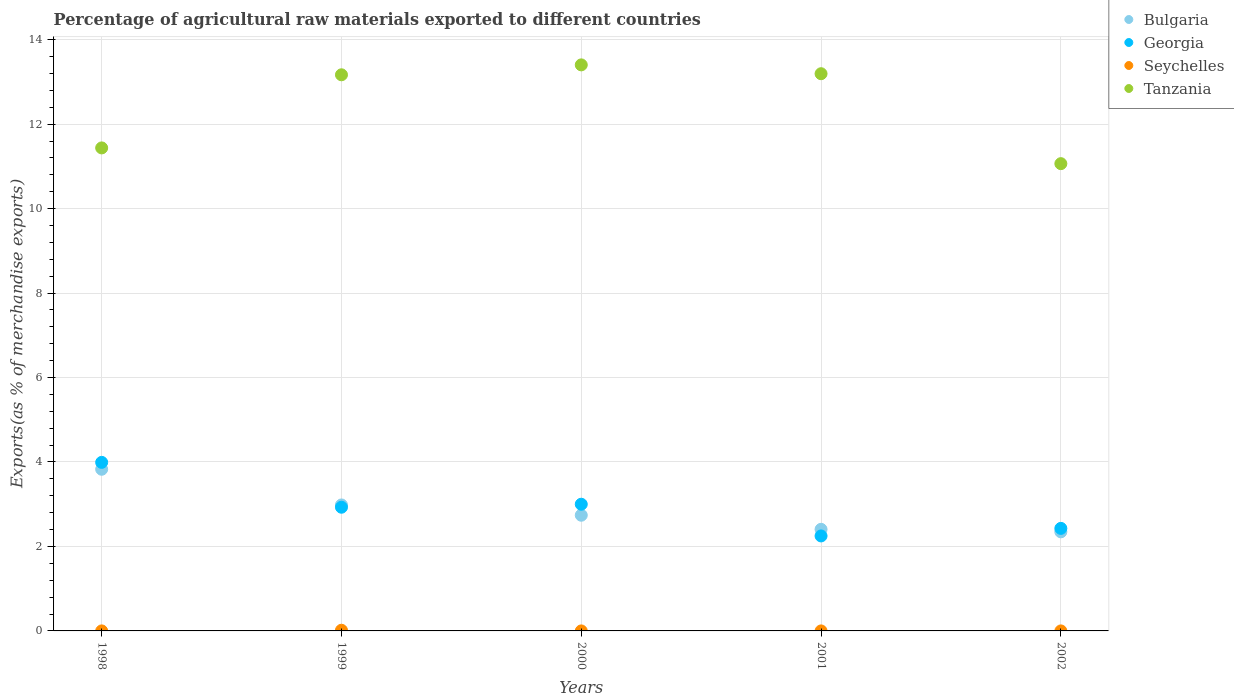How many different coloured dotlines are there?
Offer a terse response. 4. What is the percentage of exports to different countries in Bulgaria in 2000?
Provide a succinct answer. 2.74. Across all years, what is the maximum percentage of exports to different countries in Seychelles?
Your response must be concise. 0.02. Across all years, what is the minimum percentage of exports to different countries in Georgia?
Provide a succinct answer. 2.25. In which year was the percentage of exports to different countries in Georgia maximum?
Make the answer very short. 1998. What is the total percentage of exports to different countries in Seychelles in the graph?
Give a very brief answer. 0.02. What is the difference between the percentage of exports to different countries in Tanzania in 1999 and that in 2002?
Your answer should be very brief. 2.1. What is the difference between the percentage of exports to different countries in Georgia in 2002 and the percentage of exports to different countries in Bulgaria in 1999?
Your answer should be very brief. -0.55. What is the average percentage of exports to different countries in Bulgaria per year?
Your answer should be very brief. 2.86. In the year 1999, what is the difference between the percentage of exports to different countries in Seychelles and percentage of exports to different countries in Bulgaria?
Your response must be concise. -2.97. In how many years, is the percentage of exports to different countries in Tanzania greater than 12.8 %?
Ensure brevity in your answer.  3. What is the ratio of the percentage of exports to different countries in Georgia in 1999 to that in 2002?
Provide a succinct answer. 1.21. Is the percentage of exports to different countries in Tanzania in 1998 less than that in 2001?
Make the answer very short. Yes. What is the difference between the highest and the second highest percentage of exports to different countries in Bulgaria?
Give a very brief answer. 0.85. What is the difference between the highest and the lowest percentage of exports to different countries in Georgia?
Offer a very short reply. 1.74. In how many years, is the percentage of exports to different countries in Seychelles greater than the average percentage of exports to different countries in Seychelles taken over all years?
Your answer should be compact. 1. Is it the case that in every year, the sum of the percentage of exports to different countries in Georgia and percentage of exports to different countries in Tanzania  is greater than the sum of percentage of exports to different countries in Seychelles and percentage of exports to different countries in Bulgaria?
Your answer should be compact. Yes. How many dotlines are there?
Provide a succinct answer. 4. What is the difference between two consecutive major ticks on the Y-axis?
Offer a terse response. 2. How are the legend labels stacked?
Your response must be concise. Vertical. What is the title of the graph?
Offer a very short reply. Percentage of agricultural raw materials exported to different countries. What is the label or title of the X-axis?
Offer a terse response. Years. What is the label or title of the Y-axis?
Offer a very short reply. Exports(as % of merchandise exports). What is the Exports(as % of merchandise exports) of Bulgaria in 1998?
Provide a succinct answer. 3.83. What is the Exports(as % of merchandise exports) in Georgia in 1998?
Provide a short and direct response. 3.99. What is the Exports(as % of merchandise exports) of Seychelles in 1998?
Keep it short and to the point. 0. What is the Exports(as % of merchandise exports) in Tanzania in 1998?
Keep it short and to the point. 11.44. What is the Exports(as % of merchandise exports) of Bulgaria in 1999?
Make the answer very short. 2.98. What is the Exports(as % of merchandise exports) in Georgia in 1999?
Your answer should be compact. 2.93. What is the Exports(as % of merchandise exports) of Seychelles in 1999?
Keep it short and to the point. 0.02. What is the Exports(as % of merchandise exports) of Tanzania in 1999?
Offer a terse response. 13.17. What is the Exports(as % of merchandise exports) of Bulgaria in 2000?
Provide a succinct answer. 2.74. What is the Exports(as % of merchandise exports) of Georgia in 2000?
Keep it short and to the point. 3. What is the Exports(as % of merchandise exports) in Seychelles in 2000?
Ensure brevity in your answer.  0. What is the Exports(as % of merchandise exports) of Tanzania in 2000?
Offer a very short reply. 13.4. What is the Exports(as % of merchandise exports) of Bulgaria in 2001?
Your response must be concise. 2.41. What is the Exports(as % of merchandise exports) of Georgia in 2001?
Keep it short and to the point. 2.25. What is the Exports(as % of merchandise exports) of Seychelles in 2001?
Your answer should be compact. 0. What is the Exports(as % of merchandise exports) of Tanzania in 2001?
Ensure brevity in your answer.  13.19. What is the Exports(as % of merchandise exports) of Bulgaria in 2002?
Keep it short and to the point. 2.35. What is the Exports(as % of merchandise exports) in Georgia in 2002?
Offer a terse response. 2.43. What is the Exports(as % of merchandise exports) in Seychelles in 2002?
Offer a very short reply. 0. What is the Exports(as % of merchandise exports) in Tanzania in 2002?
Make the answer very short. 11.06. Across all years, what is the maximum Exports(as % of merchandise exports) in Bulgaria?
Offer a very short reply. 3.83. Across all years, what is the maximum Exports(as % of merchandise exports) of Georgia?
Give a very brief answer. 3.99. Across all years, what is the maximum Exports(as % of merchandise exports) of Seychelles?
Ensure brevity in your answer.  0.02. Across all years, what is the maximum Exports(as % of merchandise exports) of Tanzania?
Offer a very short reply. 13.4. Across all years, what is the minimum Exports(as % of merchandise exports) of Bulgaria?
Ensure brevity in your answer.  2.35. Across all years, what is the minimum Exports(as % of merchandise exports) in Georgia?
Provide a succinct answer. 2.25. Across all years, what is the minimum Exports(as % of merchandise exports) in Seychelles?
Ensure brevity in your answer.  0. Across all years, what is the minimum Exports(as % of merchandise exports) in Tanzania?
Your answer should be compact. 11.06. What is the total Exports(as % of merchandise exports) in Bulgaria in the graph?
Ensure brevity in your answer.  14.3. What is the total Exports(as % of merchandise exports) in Georgia in the graph?
Provide a succinct answer. 14.6. What is the total Exports(as % of merchandise exports) of Seychelles in the graph?
Your answer should be compact. 0.02. What is the total Exports(as % of merchandise exports) in Tanzania in the graph?
Provide a short and direct response. 62.27. What is the difference between the Exports(as % of merchandise exports) in Bulgaria in 1998 and that in 1999?
Your response must be concise. 0.85. What is the difference between the Exports(as % of merchandise exports) in Georgia in 1998 and that in 1999?
Give a very brief answer. 1.06. What is the difference between the Exports(as % of merchandise exports) in Seychelles in 1998 and that in 1999?
Ensure brevity in your answer.  -0.02. What is the difference between the Exports(as % of merchandise exports) in Tanzania in 1998 and that in 1999?
Give a very brief answer. -1.73. What is the difference between the Exports(as % of merchandise exports) in Bulgaria in 1998 and that in 2000?
Your answer should be compact. 1.09. What is the difference between the Exports(as % of merchandise exports) in Georgia in 1998 and that in 2000?
Offer a terse response. 0.99. What is the difference between the Exports(as % of merchandise exports) in Tanzania in 1998 and that in 2000?
Your answer should be compact. -1.97. What is the difference between the Exports(as % of merchandise exports) in Bulgaria in 1998 and that in 2001?
Keep it short and to the point. 1.42. What is the difference between the Exports(as % of merchandise exports) of Georgia in 1998 and that in 2001?
Offer a very short reply. 1.74. What is the difference between the Exports(as % of merchandise exports) in Tanzania in 1998 and that in 2001?
Make the answer very short. -1.76. What is the difference between the Exports(as % of merchandise exports) of Bulgaria in 1998 and that in 2002?
Your answer should be very brief. 1.48. What is the difference between the Exports(as % of merchandise exports) in Georgia in 1998 and that in 2002?
Offer a terse response. 1.56. What is the difference between the Exports(as % of merchandise exports) of Seychelles in 1998 and that in 2002?
Ensure brevity in your answer.  0. What is the difference between the Exports(as % of merchandise exports) in Tanzania in 1998 and that in 2002?
Your answer should be compact. 0.37. What is the difference between the Exports(as % of merchandise exports) in Bulgaria in 1999 and that in 2000?
Give a very brief answer. 0.24. What is the difference between the Exports(as % of merchandise exports) in Georgia in 1999 and that in 2000?
Your answer should be very brief. -0.07. What is the difference between the Exports(as % of merchandise exports) of Seychelles in 1999 and that in 2000?
Offer a very short reply. 0.02. What is the difference between the Exports(as % of merchandise exports) in Tanzania in 1999 and that in 2000?
Keep it short and to the point. -0.23. What is the difference between the Exports(as % of merchandise exports) of Bulgaria in 1999 and that in 2001?
Provide a succinct answer. 0.58. What is the difference between the Exports(as % of merchandise exports) in Georgia in 1999 and that in 2001?
Keep it short and to the point. 0.68. What is the difference between the Exports(as % of merchandise exports) in Seychelles in 1999 and that in 2001?
Ensure brevity in your answer.  0.02. What is the difference between the Exports(as % of merchandise exports) of Tanzania in 1999 and that in 2001?
Offer a terse response. -0.03. What is the difference between the Exports(as % of merchandise exports) in Bulgaria in 1999 and that in 2002?
Provide a short and direct response. 0.64. What is the difference between the Exports(as % of merchandise exports) in Georgia in 1999 and that in 2002?
Your answer should be very brief. 0.5. What is the difference between the Exports(as % of merchandise exports) of Seychelles in 1999 and that in 2002?
Keep it short and to the point. 0.02. What is the difference between the Exports(as % of merchandise exports) of Tanzania in 1999 and that in 2002?
Your answer should be compact. 2.1. What is the difference between the Exports(as % of merchandise exports) of Bulgaria in 2000 and that in 2001?
Provide a short and direct response. 0.33. What is the difference between the Exports(as % of merchandise exports) of Georgia in 2000 and that in 2001?
Your response must be concise. 0.75. What is the difference between the Exports(as % of merchandise exports) of Seychelles in 2000 and that in 2001?
Offer a terse response. -0. What is the difference between the Exports(as % of merchandise exports) in Tanzania in 2000 and that in 2001?
Give a very brief answer. 0.21. What is the difference between the Exports(as % of merchandise exports) in Bulgaria in 2000 and that in 2002?
Your answer should be compact. 0.39. What is the difference between the Exports(as % of merchandise exports) in Georgia in 2000 and that in 2002?
Offer a very short reply. 0.57. What is the difference between the Exports(as % of merchandise exports) of Seychelles in 2000 and that in 2002?
Give a very brief answer. -0. What is the difference between the Exports(as % of merchandise exports) in Tanzania in 2000 and that in 2002?
Make the answer very short. 2.34. What is the difference between the Exports(as % of merchandise exports) of Bulgaria in 2001 and that in 2002?
Provide a succinct answer. 0.06. What is the difference between the Exports(as % of merchandise exports) in Georgia in 2001 and that in 2002?
Your answer should be very brief. -0.18. What is the difference between the Exports(as % of merchandise exports) of Seychelles in 2001 and that in 2002?
Offer a terse response. 0. What is the difference between the Exports(as % of merchandise exports) in Tanzania in 2001 and that in 2002?
Your answer should be compact. 2.13. What is the difference between the Exports(as % of merchandise exports) in Bulgaria in 1998 and the Exports(as % of merchandise exports) in Georgia in 1999?
Keep it short and to the point. 0.9. What is the difference between the Exports(as % of merchandise exports) in Bulgaria in 1998 and the Exports(as % of merchandise exports) in Seychelles in 1999?
Offer a very short reply. 3.81. What is the difference between the Exports(as % of merchandise exports) of Bulgaria in 1998 and the Exports(as % of merchandise exports) of Tanzania in 1999?
Provide a succinct answer. -9.34. What is the difference between the Exports(as % of merchandise exports) in Georgia in 1998 and the Exports(as % of merchandise exports) in Seychelles in 1999?
Ensure brevity in your answer.  3.97. What is the difference between the Exports(as % of merchandise exports) in Georgia in 1998 and the Exports(as % of merchandise exports) in Tanzania in 1999?
Your answer should be compact. -9.18. What is the difference between the Exports(as % of merchandise exports) of Seychelles in 1998 and the Exports(as % of merchandise exports) of Tanzania in 1999?
Offer a very short reply. -13.17. What is the difference between the Exports(as % of merchandise exports) in Bulgaria in 1998 and the Exports(as % of merchandise exports) in Georgia in 2000?
Provide a short and direct response. 0.83. What is the difference between the Exports(as % of merchandise exports) of Bulgaria in 1998 and the Exports(as % of merchandise exports) of Seychelles in 2000?
Provide a succinct answer. 3.83. What is the difference between the Exports(as % of merchandise exports) of Bulgaria in 1998 and the Exports(as % of merchandise exports) of Tanzania in 2000?
Ensure brevity in your answer.  -9.58. What is the difference between the Exports(as % of merchandise exports) of Georgia in 1998 and the Exports(as % of merchandise exports) of Seychelles in 2000?
Your response must be concise. 3.99. What is the difference between the Exports(as % of merchandise exports) of Georgia in 1998 and the Exports(as % of merchandise exports) of Tanzania in 2000?
Offer a very short reply. -9.41. What is the difference between the Exports(as % of merchandise exports) of Seychelles in 1998 and the Exports(as % of merchandise exports) of Tanzania in 2000?
Provide a short and direct response. -13.4. What is the difference between the Exports(as % of merchandise exports) of Bulgaria in 1998 and the Exports(as % of merchandise exports) of Georgia in 2001?
Offer a very short reply. 1.58. What is the difference between the Exports(as % of merchandise exports) in Bulgaria in 1998 and the Exports(as % of merchandise exports) in Seychelles in 2001?
Offer a terse response. 3.83. What is the difference between the Exports(as % of merchandise exports) in Bulgaria in 1998 and the Exports(as % of merchandise exports) in Tanzania in 2001?
Your answer should be very brief. -9.37. What is the difference between the Exports(as % of merchandise exports) in Georgia in 1998 and the Exports(as % of merchandise exports) in Seychelles in 2001?
Your answer should be compact. 3.99. What is the difference between the Exports(as % of merchandise exports) of Georgia in 1998 and the Exports(as % of merchandise exports) of Tanzania in 2001?
Offer a terse response. -9.2. What is the difference between the Exports(as % of merchandise exports) of Seychelles in 1998 and the Exports(as % of merchandise exports) of Tanzania in 2001?
Your response must be concise. -13.19. What is the difference between the Exports(as % of merchandise exports) of Bulgaria in 1998 and the Exports(as % of merchandise exports) of Georgia in 2002?
Offer a terse response. 1.4. What is the difference between the Exports(as % of merchandise exports) in Bulgaria in 1998 and the Exports(as % of merchandise exports) in Seychelles in 2002?
Keep it short and to the point. 3.83. What is the difference between the Exports(as % of merchandise exports) in Bulgaria in 1998 and the Exports(as % of merchandise exports) in Tanzania in 2002?
Give a very brief answer. -7.24. What is the difference between the Exports(as % of merchandise exports) of Georgia in 1998 and the Exports(as % of merchandise exports) of Seychelles in 2002?
Give a very brief answer. 3.99. What is the difference between the Exports(as % of merchandise exports) of Georgia in 1998 and the Exports(as % of merchandise exports) of Tanzania in 2002?
Provide a short and direct response. -7.07. What is the difference between the Exports(as % of merchandise exports) of Seychelles in 1998 and the Exports(as % of merchandise exports) of Tanzania in 2002?
Give a very brief answer. -11.06. What is the difference between the Exports(as % of merchandise exports) in Bulgaria in 1999 and the Exports(as % of merchandise exports) in Georgia in 2000?
Make the answer very short. -0.02. What is the difference between the Exports(as % of merchandise exports) of Bulgaria in 1999 and the Exports(as % of merchandise exports) of Seychelles in 2000?
Your response must be concise. 2.98. What is the difference between the Exports(as % of merchandise exports) in Bulgaria in 1999 and the Exports(as % of merchandise exports) in Tanzania in 2000?
Your response must be concise. -10.42. What is the difference between the Exports(as % of merchandise exports) in Georgia in 1999 and the Exports(as % of merchandise exports) in Seychelles in 2000?
Ensure brevity in your answer.  2.93. What is the difference between the Exports(as % of merchandise exports) in Georgia in 1999 and the Exports(as % of merchandise exports) in Tanzania in 2000?
Offer a very short reply. -10.47. What is the difference between the Exports(as % of merchandise exports) in Seychelles in 1999 and the Exports(as % of merchandise exports) in Tanzania in 2000?
Make the answer very short. -13.39. What is the difference between the Exports(as % of merchandise exports) of Bulgaria in 1999 and the Exports(as % of merchandise exports) of Georgia in 2001?
Provide a short and direct response. 0.73. What is the difference between the Exports(as % of merchandise exports) in Bulgaria in 1999 and the Exports(as % of merchandise exports) in Seychelles in 2001?
Your answer should be compact. 2.98. What is the difference between the Exports(as % of merchandise exports) in Bulgaria in 1999 and the Exports(as % of merchandise exports) in Tanzania in 2001?
Make the answer very short. -10.21. What is the difference between the Exports(as % of merchandise exports) in Georgia in 1999 and the Exports(as % of merchandise exports) in Seychelles in 2001?
Provide a short and direct response. 2.93. What is the difference between the Exports(as % of merchandise exports) of Georgia in 1999 and the Exports(as % of merchandise exports) of Tanzania in 2001?
Keep it short and to the point. -10.26. What is the difference between the Exports(as % of merchandise exports) of Seychelles in 1999 and the Exports(as % of merchandise exports) of Tanzania in 2001?
Provide a short and direct response. -13.18. What is the difference between the Exports(as % of merchandise exports) of Bulgaria in 1999 and the Exports(as % of merchandise exports) of Georgia in 2002?
Offer a very short reply. 0.55. What is the difference between the Exports(as % of merchandise exports) in Bulgaria in 1999 and the Exports(as % of merchandise exports) in Seychelles in 2002?
Ensure brevity in your answer.  2.98. What is the difference between the Exports(as % of merchandise exports) of Bulgaria in 1999 and the Exports(as % of merchandise exports) of Tanzania in 2002?
Offer a terse response. -8.08. What is the difference between the Exports(as % of merchandise exports) of Georgia in 1999 and the Exports(as % of merchandise exports) of Seychelles in 2002?
Give a very brief answer. 2.93. What is the difference between the Exports(as % of merchandise exports) in Georgia in 1999 and the Exports(as % of merchandise exports) in Tanzania in 2002?
Your answer should be compact. -8.14. What is the difference between the Exports(as % of merchandise exports) of Seychelles in 1999 and the Exports(as % of merchandise exports) of Tanzania in 2002?
Your answer should be compact. -11.05. What is the difference between the Exports(as % of merchandise exports) of Bulgaria in 2000 and the Exports(as % of merchandise exports) of Georgia in 2001?
Offer a very short reply. 0.49. What is the difference between the Exports(as % of merchandise exports) of Bulgaria in 2000 and the Exports(as % of merchandise exports) of Seychelles in 2001?
Give a very brief answer. 2.74. What is the difference between the Exports(as % of merchandise exports) of Bulgaria in 2000 and the Exports(as % of merchandise exports) of Tanzania in 2001?
Offer a terse response. -10.45. What is the difference between the Exports(as % of merchandise exports) in Georgia in 2000 and the Exports(as % of merchandise exports) in Seychelles in 2001?
Ensure brevity in your answer.  3. What is the difference between the Exports(as % of merchandise exports) of Georgia in 2000 and the Exports(as % of merchandise exports) of Tanzania in 2001?
Your response must be concise. -10.19. What is the difference between the Exports(as % of merchandise exports) in Seychelles in 2000 and the Exports(as % of merchandise exports) in Tanzania in 2001?
Offer a terse response. -13.19. What is the difference between the Exports(as % of merchandise exports) of Bulgaria in 2000 and the Exports(as % of merchandise exports) of Georgia in 2002?
Offer a terse response. 0.31. What is the difference between the Exports(as % of merchandise exports) of Bulgaria in 2000 and the Exports(as % of merchandise exports) of Seychelles in 2002?
Give a very brief answer. 2.74. What is the difference between the Exports(as % of merchandise exports) of Bulgaria in 2000 and the Exports(as % of merchandise exports) of Tanzania in 2002?
Your answer should be compact. -8.32. What is the difference between the Exports(as % of merchandise exports) in Georgia in 2000 and the Exports(as % of merchandise exports) in Seychelles in 2002?
Offer a terse response. 3. What is the difference between the Exports(as % of merchandise exports) of Georgia in 2000 and the Exports(as % of merchandise exports) of Tanzania in 2002?
Keep it short and to the point. -8.06. What is the difference between the Exports(as % of merchandise exports) in Seychelles in 2000 and the Exports(as % of merchandise exports) in Tanzania in 2002?
Offer a terse response. -11.06. What is the difference between the Exports(as % of merchandise exports) in Bulgaria in 2001 and the Exports(as % of merchandise exports) in Georgia in 2002?
Ensure brevity in your answer.  -0.02. What is the difference between the Exports(as % of merchandise exports) in Bulgaria in 2001 and the Exports(as % of merchandise exports) in Seychelles in 2002?
Offer a terse response. 2.41. What is the difference between the Exports(as % of merchandise exports) of Bulgaria in 2001 and the Exports(as % of merchandise exports) of Tanzania in 2002?
Keep it short and to the point. -8.66. What is the difference between the Exports(as % of merchandise exports) of Georgia in 2001 and the Exports(as % of merchandise exports) of Seychelles in 2002?
Make the answer very short. 2.25. What is the difference between the Exports(as % of merchandise exports) in Georgia in 2001 and the Exports(as % of merchandise exports) in Tanzania in 2002?
Keep it short and to the point. -8.81. What is the difference between the Exports(as % of merchandise exports) of Seychelles in 2001 and the Exports(as % of merchandise exports) of Tanzania in 2002?
Your response must be concise. -11.06. What is the average Exports(as % of merchandise exports) in Bulgaria per year?
Your answer should be very brief. 2.86. What is the average Exports(as % of merchandise exports) in Georgia per year?
Make the answer very short. 2.92. What is the average Exports(as % of merchandise exports) in Seychelles per year?
Offer a terse response. 0. What is the average Exports(as % of merchandise exports) in Tanzania per year?
Ensure brevity in your answer.  12.45. In the year 1998, what is the difference between the Exports(as % of merchandise exports) in Bulgaria and Exports(as % of merchandise exports) in Georgia?
Provide a succinct answer. -0.16. In the year 1998, what is the difference between the Exports(as % of merchandise exports) in Bulgaria and Exports(as % of merchandise exports) in Seychelles?
Your answer should be very brief. 3.83. In the year 1998, what is the difference between the Exports(as % of merchandise exports) of Bulgaria and Exports(as % of merchandise exports) of Tanzania?
Ensure brevity in your answer.  -7.61. In the year 1998, what is the difference between the Exports(as % of merchandise exports) of Georgia and Exports(as % of merchandise exports) of Seychelles?
Provide a succinct answer. 3.99. In the year 1998, what is the difference between the Exports(as % of merchandise exports) in Georgia and Exports(as % of merchandise exports) in Tanzania?
Offer a terse response. -7.45. In the year 1998, what is the difference between the Exports(as % of merchandise exports) in Seychelles and Exports(as % of merchandise exports) in Tanzania?
Ensure brevity in your answer.  -11.44. In the year 1999, what is the difference between the Exports(as % of merchandise exports) in Bulgaria and Exports(as % of merchandise exports) in Georgia?
Keep it short and to the point. 0.05. In the year 1999, what is the difference between the Exports(as % of merchandise exports) in Bulgaria and Exports(as % of merchandise exports) in Seychelles?
Offer a terse response. 2.97. In the year 1999, what is the difference between the Exports(as % of merchandise exports) in Bulgaria and Exports(as % of merchandise exports) in Tanzania?
Provide a succinct answer. -10.19. In the year 1999, what is the difference between the Exports(as % of merchandise exports) of Georgia and Exports(as % of merchandise exports) of Seychelles?
Offer a terse response. 2.91. In the year 1999, what is the difference between the Exports(as % of merchandise exports) of Georgia and Exports(as % of merchandise exports) of Tanzania?
Your answer should be compact. -10.24. In the year 1999, what is the difference between the Exports(as % of merchandise exports) in Seychelles and Exports(as % of merchandise exports) in Tanzania?
Give a very brief answer. -13.15. In the year 2000, what is the difference between the Exports(as % of merchandise exports) of Bulgaria and Exports(as % of merchandise exports) of Georgia?
Your answer should be compact. -0.26. In the year 2000, what is the difference between the Exports(as % of merchandise exports) in Bulgaria and Exports(as % of merchandise exports) in Seychelles?
Give a very brief answer. 2.74. In the year 2000, what is the difference between the Exports(as % of merchandise exports) in Bulgaria and Exports(as % of merchandise exports) in Tanzania?
Your response must be concise. -10.66. In the year 2000, what is the difference between the Exports(as % of merchandise exports) in Georgia and Exports(as % of merchandise exports) in Seychelles?
Ensure brevity in your answer.  3. In the year 2000, what is the difference between the Exports(as % of merchandise exports) of Georgia and Exports(as % of merchandise exports) of Tanzania?
Offer a very short reply. -10.4. In the year 2000, what is the difference between the Exports(as % of merchandise exports) in Seychelles and Exports(as % of merchandise exports) in Tanzania?
Give a very brief answer. -13.4. In the year 2001, what is the difference between the Exports(as % of merchandise exports) in Bulgaria and Exports(as % of merchandise exports) in Georgia?
Your answer should be very brief. 0.16. In the year 2001, what is the difference between the Exports(as % of merchandise exports) of Bulgaria and Exports(as % of merchandise exports) of Seychelles?
Provide a succinct answer. 2.41. In the year 2001, what is the difference between the Exports(as % of merchandise exports) in Bulgaria and Exports(as % of merchandise exports) in Tanzania?
Your answer should be very brief. -10.79. In the year 2001, what is the difference between the Exports(as % of merchandise exports) in Georgia and Exports(as % of merchandise exports) in Seychelles?
Give a very brief answer. 2.25. In the year 2001, what is the difference between the Exports(as % of merchandise exports) of Georgia and Exports(as % of merchandise exports) of Tanzania?
Offer a very short reply. -10.94. In the year 2001, what is the difference between the Exports(as % of merchandise exports) in Seychelles and Exports(as % of merchandise exports) in Tanzania?
Ensure brevity in your answer.  -13.19. In the year 2002, what is the difference between the Exports(as % of merchandise exports) in Bulgaria and Exports(as % of merchandise exports) in Georgia?
Provide a succinct answer. -0.08. In the year 2002, what is the difference between the Exports(as % of merchandise exports) of Bulgaria and Exports(as % of merchandise exports) of Seychelles?
Offer a very short reply. 2.35. In the year 2002, what is the difference between the Exports(as % of merchandise exports) of Bulgaria and Exports(as % of merchandise exports) of Tanzania?
Keep it short and to the point. -8.72. In the year 2002, what is the difference between the Exports(as % of merchandise exports) in Georgia and Exports(as % of merchandise exports) in Seychelles?
Provide a short and direct response. 2.43. In the year 2002, what is the difference between the Exports(as % of merchandise exports) in Georgia and Exports(as % of merchandise exports) in Tanzania?
Ensure brevity in your answer.  -8.64. In the year 2002, what is the difference between the Exports(as % of merchandise exports) of Seychelles and Exports(as % of merchandise exports) of Tanzania?
Provide a short and direct response. -11.06. What is the ratio of the Exports(as % of merchandise exports) in Bulgaria in 1998 to that in 1999?
Keep it short and to the point. 1.28. What is the ratio of the Exports(as % of merchandise exports) in Georgia in 1998 to that in 1999?
Keep it short and to the point. 1.36. What is the ratio of the Exports(as % of merchandise exports) of Seychelles in 1998 to that in 1999?
Give a very brief answer. 0.03. What is the ratio of the Exports(as % of merchandise exports) of Tanzania in 1998 to that in 1999?
Provide a succinct answer. 0.87. What is the ratio of the Exports(as % of merchandise exports) of Bulgaria in 1998 to that in 2000?
Provide a succinct answer. 1.4. What is the ratio of the Exports(as % of merchandise exports) in Georgia in 1998 to that in 2000?
Give a very brief answer. 1.33. What is the ratio of the Exports(as % of merchandise exports) of Seychelles in 1998 to that in 2000?
Provide a succinct answer. 3.86. What is the ratio of the Exports(as % of merchandise exports) of Tanzania in 1998 to that in 2000?
Your response must be concise. 0.85. What is the ratio of the Exports(as % of merchandise exports) in Bulgaria in 1998 to that in 2001?
Ensure brevity in your answer.  1.59. What is the ratio of the Exports(as % of merchandise exports) in Georgia in 1998 to that in 2001?
Ensure brevity in your answer.  1.77. What is the ratio of the Exports(as % of merchandise exports) of Seychelles in 1998 to that in 2001?
Your answer should be compact. 3.34. What is the ratio of the Exports(as % of merchandise exports) of Tanzania in 1998 to that in 2001?
Provide a succinct answer. 0.87. What is the ratio of the Exports(as % of merchandise exports) in Bulgaria in 1998 to that in 2002?
Provide a short and direct response. 1.63. What is the ratio of the Exports(as % of merchandise exports) of Georgia in 1998 to that in 2002?
Your answer should be very brief. 1.64. What is the ratio of the Exports(as % of merchandise exports) in Seychelles in 1998 to that in 2002?
Keep it short and to the point. 3.57. What is the ratio of the Exports(as % of merchandise exports) in Tanzania in 1998 to that in 2002?
Give a very brief answer. 1.03. What is the ratio of the Exports(as % of merchandise exports) in Bulgaria in 1999 to that in 2000?
Keep it short and to the point. 1.09. What is the ratio of the Exports(as % of merchandise exports) of Georgia in 1999 to that in 2000?
Give a very brief answer. 0.98. What is the ratio of the Exports(as % of merchandise exports) of Seychelles in 1999 to that in 2000?
Ensure brevity in your answer.  138.94. What is the ratio of the Exports(as % of merchandise exports) in Tanzania in 1999 to that in 2000?
Offer a very short reply. 0.98. What is the ratio of the Exports(as % of merchandise exports) in Bulgaria in 1999 to that in 2001?
Keep it short and to the point. 1.24. What is the ratio of the Exports(as % of merchandise exports) of Georgia in 1999 to that in 2001?
Offer a very short reply. 1.3. What is the ratio of the Exports(as % of merchandise exports) in Seychelles in 1999 to that in 2001?
Offer a very short reply. 120.38. What is the ratio of the Exports(as % of merchandise exports) of Bulgaria in 1999 to that in 2002?
Your response must be concise. 1.27. What is the ratio of the Exports(as % of merchandise exports) of Georgia in 1999 to that in 2002?
Your answer should be very brief. 1.21. What is the ratio of the Exports(as % of merchandise exports) in Seychelles in 1999 to that in 2002?
Your response must be concise. 128.67. What is the ratio of the Exports(as % of merchandise exports) in Tanzania in 1999 to that in 2002?
Your answer should be compact. 1.19. What is the ratio of the Exports(as % of merchandise exports) in Bulgaria in 2000 to that in 2001?
Make the answer very short. 1.14. What is the ratio of the Exports(as % of merchandise exports) in Georgia in 2000 to that in 2001?
Your answer should be compact. 1.33. What is the ratio of the Exports(as % of merchandise exports) of Seychelles in 2000 to that in 2001?
Offer a very short reply. 0.87. What is the ratio of the Exports(as % of merchandise exports) of Tanzania in 2000 to that in 2001?
Offer a very short reply. 1.02. What is the ratio of the Exports(as % of merchandise exports) of Bulgaria in 2000 to that in 2002?
Your answer should be very brief. 1.17. What is the ratio of the Exports(as % of merchandise exports) in Georgia in 2000 to that in 2002?
Offer a very short reply. 1.24. What is the ratio of the Exports(as % of merchandise exports) in Seychelles in 2000 to that in 2002?
Provide a succinct answer. 0.93. What is the ratio of the Exports(as % of merchandise exports) of Tanzania in 2000 to that in 2002?
Ensure brevity in your answer.  1.21. What is the ratio of the Exports(as % of merchandise exports) in Bulgaria in 2001 to that in 2002?
Your answer should be compact. 1.03. What is the ratio of the Exports(as % of merchandise exports) of Georgia in 2001 to that in 2002?
Your answer should be very brief. 0.93. What is the ratio of the Exports(as % of merchandise exports) of Seychelles in 2001 to that in 2002?
Your response must be concise. 1.07. What is the ratio of the Exports(as % of merchandise exports) of Tanzania in 2001 to that in 2002?
Ensure brevity in your answer.  1.19. What is the difference between the highest and the second highest Exports(as % of merchandise exports) in Bulgaria?
Give a very brief answer. 0.85. What is the difference between the highest and the second highest Exports(as % of merchandise exports) in Seychelles?
Keep it short and to the point. 0.02. What is the difference between the highest and the second highest Exports(as % of merchandise exports) in Tanzania?
Your answer should be very brief. 0.21. What is the difference between the highest and the lowest Exports(as % of merchandise exports) of Bulgaria?
Your answer should be very brief. 1.48. What is the difference between the highest and the lowest Exports(as % of merchandise exports) of Georgia?
Offer a terse response. 1.74. What is the difference between the highest and the lowest Exports(as % of merchandise exports) of Seychelles?
Offer a very short reply. 0.02. What is the difference between the highest and the lowest Exports(as % of merchandise exports) of Tanzania?
Give a very brief answer. 2.34. 